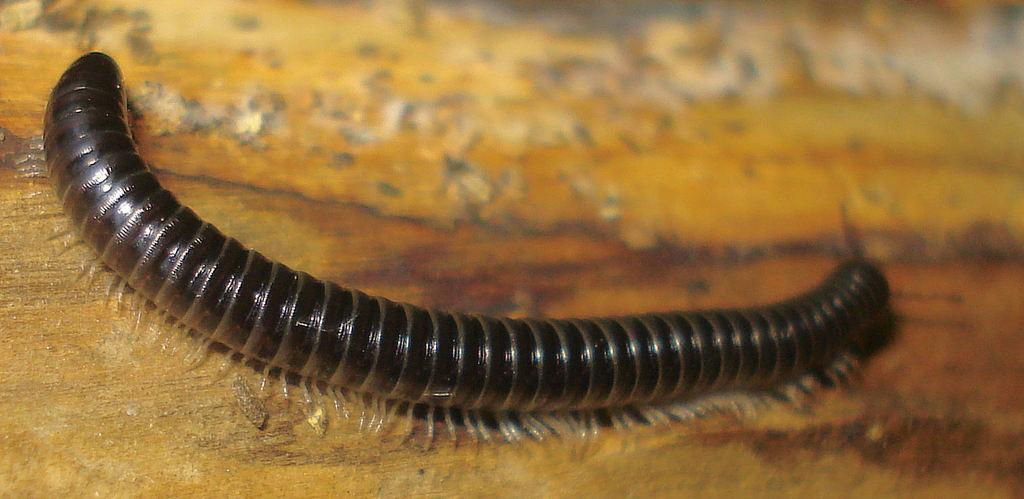What type of creature is present in the image? There is an insect in the image. What surface is the insect located on? The insect is on wood. What songs is the rabbit singing in the image? There are no rabbits or songs present in the image; it features an insect on wood. 